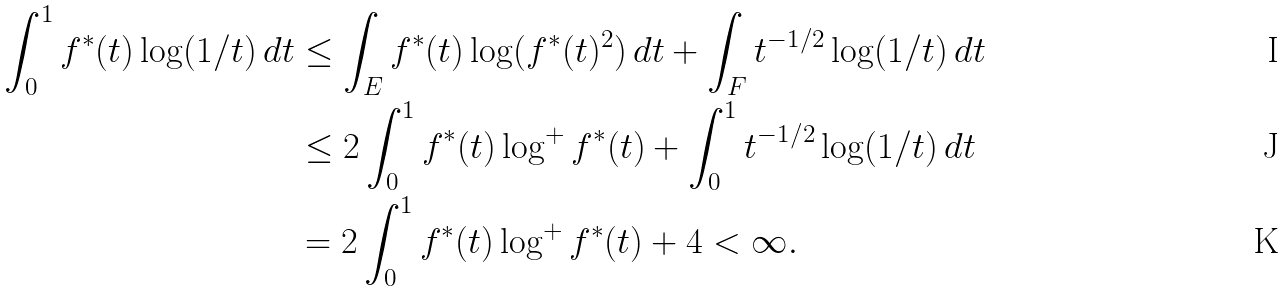Convert formula to latex. <formula><loc_0><loc_0><loc_500><loc_500>\int _ { 0 } ^ { 1 } f ^ { * } ( t ) \log ( 1 / t ) \, d t & \leq \int _ { E } f ^ { * } ( t ) \log ( f ^ { * } ( t ) ^ { 2 } ) \, d t + \int _ { F } t ^ { - 1 / 2 } \log ( 1 / t ) \, d t \\ & \leq 2 \int _ { 0 } ^ { 1 } f ^ { * } ( t ) \log ^ { + } f ^ { * } ( t ) + \int _ { 0 } ^ { 1 } t ^ { - 1 / 2 } \log ( 1 / t ) \, d t \\ & = 2 \int _ { 0 } ^ { 1 } f ^ { * } ( t ) \log ^ { + } f ^ { * } ( t ) + 4 < \infty .</formula> 